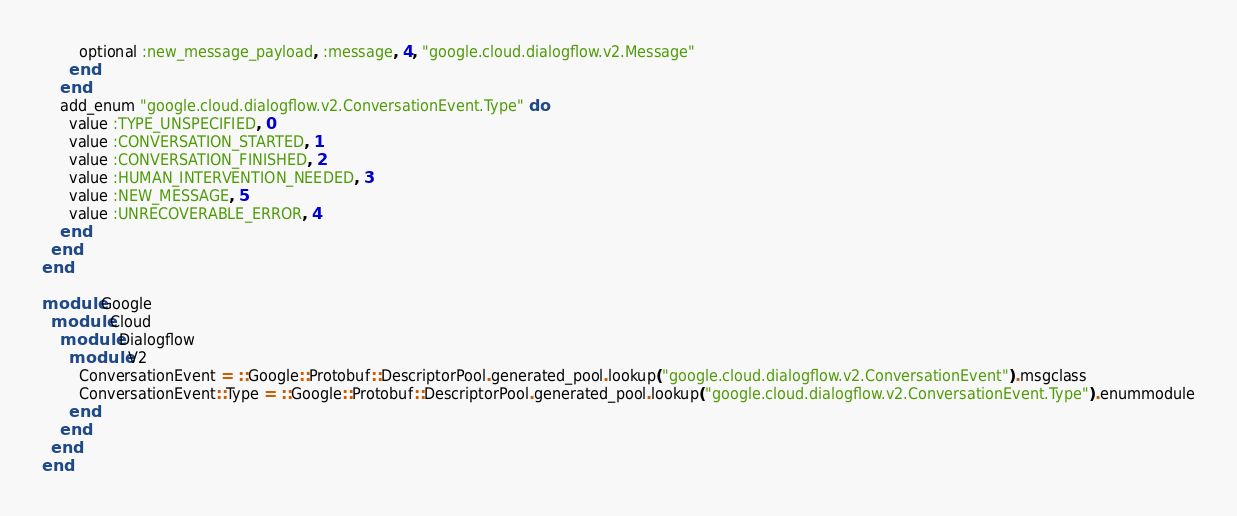<code> <loc_0><loc_0><loc_500><loc_500><_Ruby_>        optional :new_message_payload, :message, 4, "google.cloud.dialogflow.v2.Message"
      end
    end
    add_enum "google.cloud.dialogflow.v2.ConversationEvent.Type" do
      value :TYPE_UNSPECIFIED, 0
      value :CONVERSATION_STARTED, 1
      value :CONVERSATION_FINISHED, 2
      value :HUMAN_INTERVENTION_NEEDED, 3
      value :NEW_MESSAGE, 5
      value :UNRECOVERABLE_ERROR, 4
    end
  end
end

module Google
  module Cloud
    module Dialogflow
      module V2
        ConversationEvent = ::Google::Protobuf::DescriptorPool.generated_pool.lookup("google.cloud.dialogflow.v2.ConversationEvent").msgclass
        ConversationEvent::Type = ::Google::Protobuf::DescriptorPool.generated_pool.lookup("google.cloud.dialogflow.v2.ConversationEvent.Type").enummodule
      end
    end
  end
end
</code> 